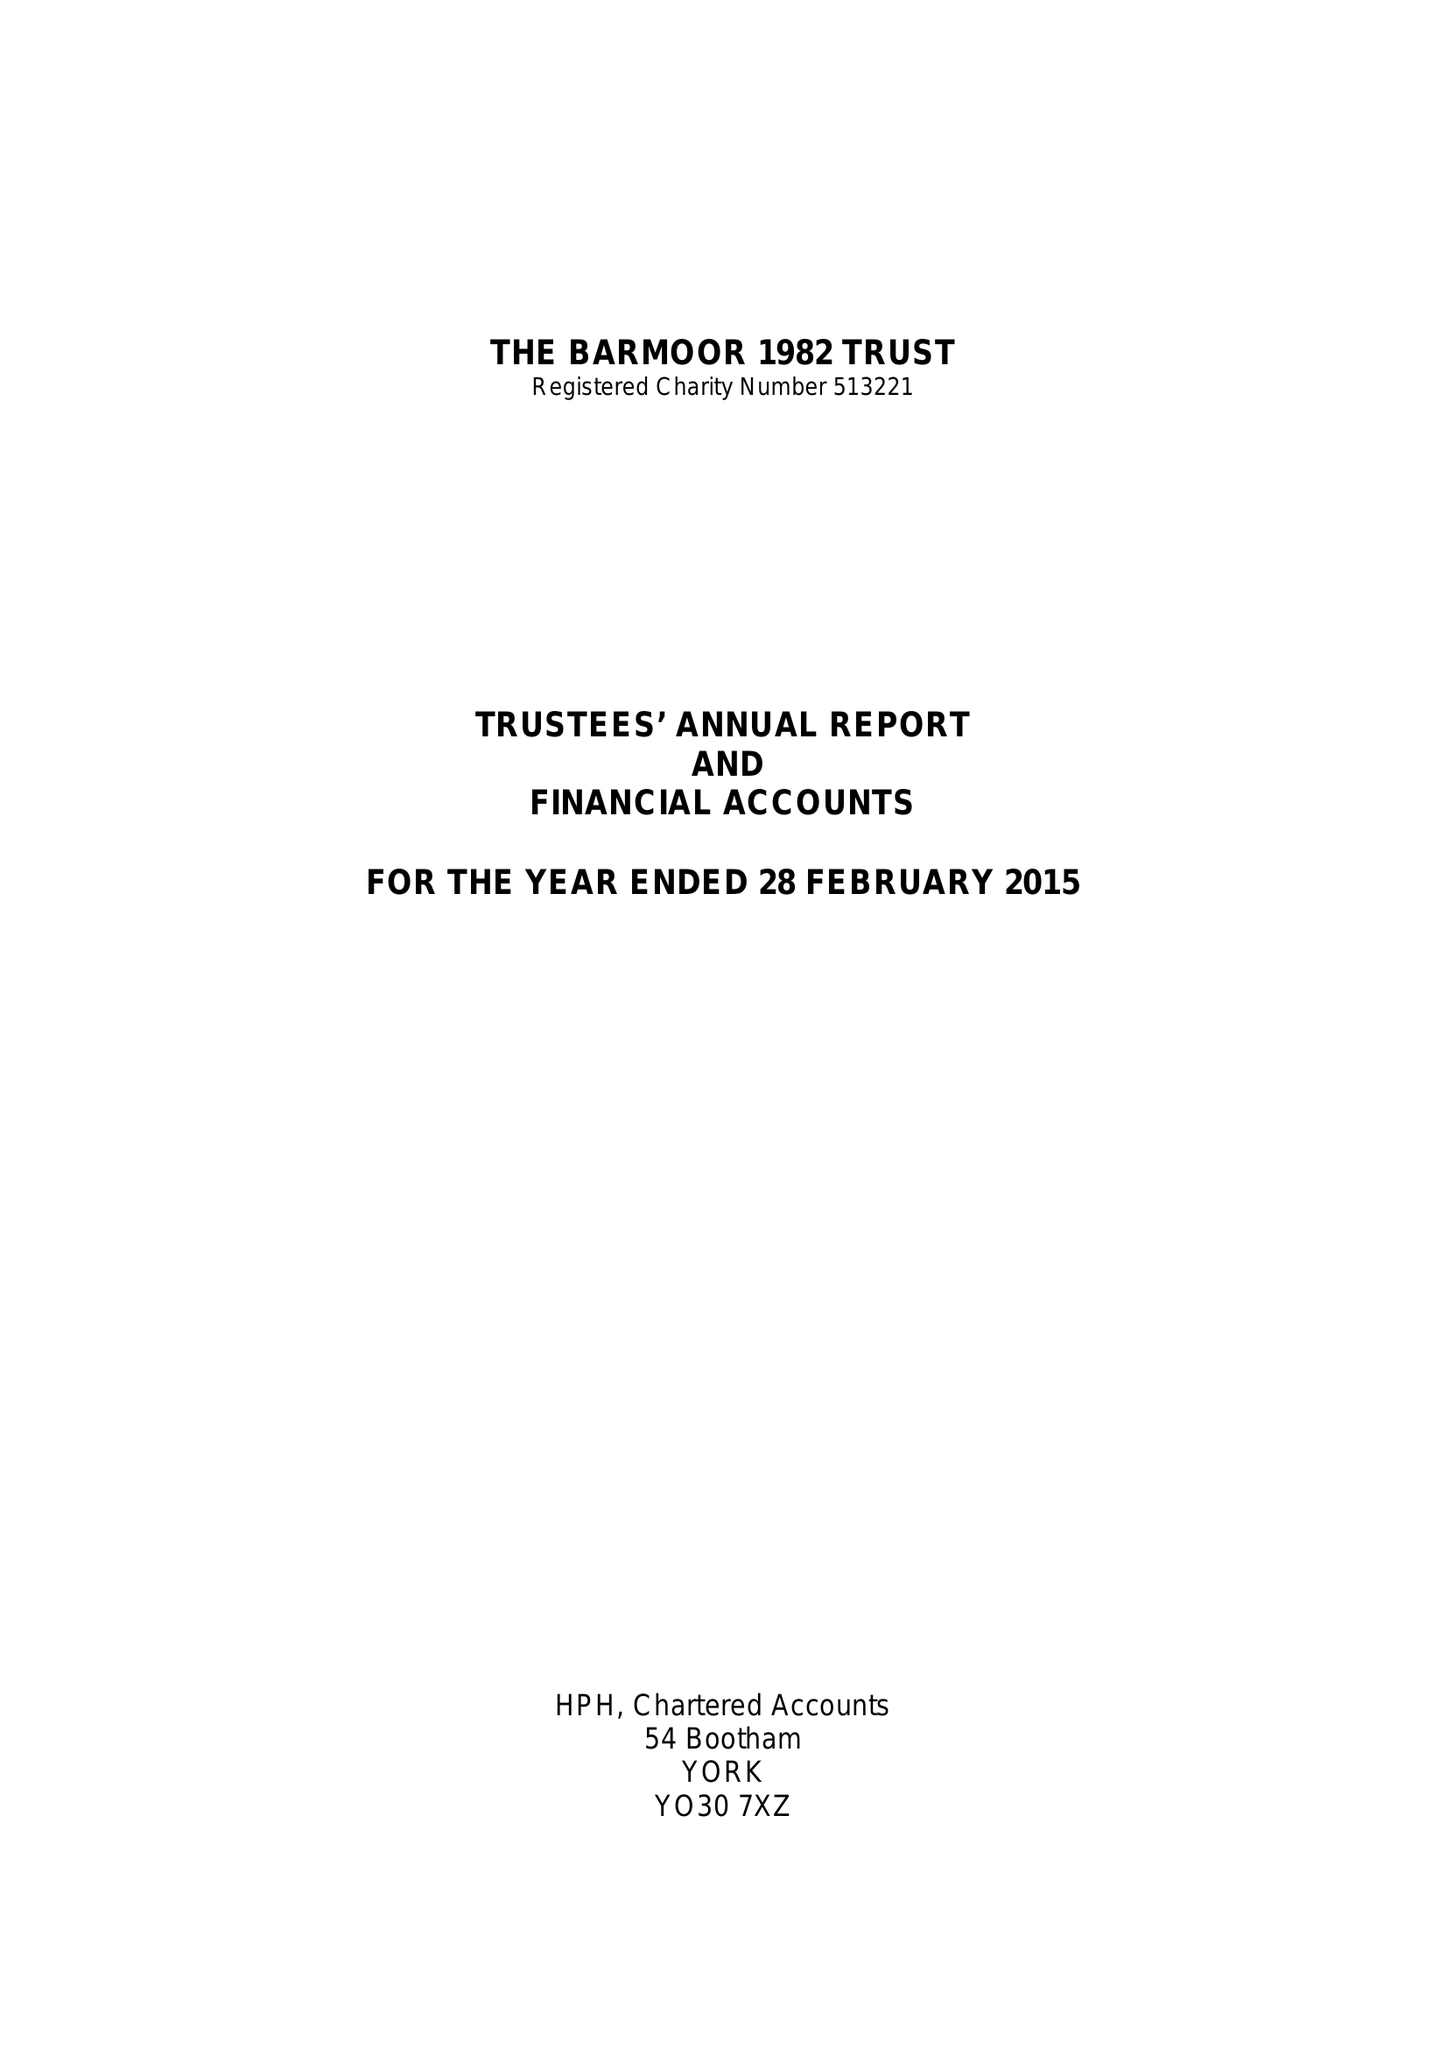What is the value for the address__postcode?
Answer the question using a single word or phrase. N17 6LB 